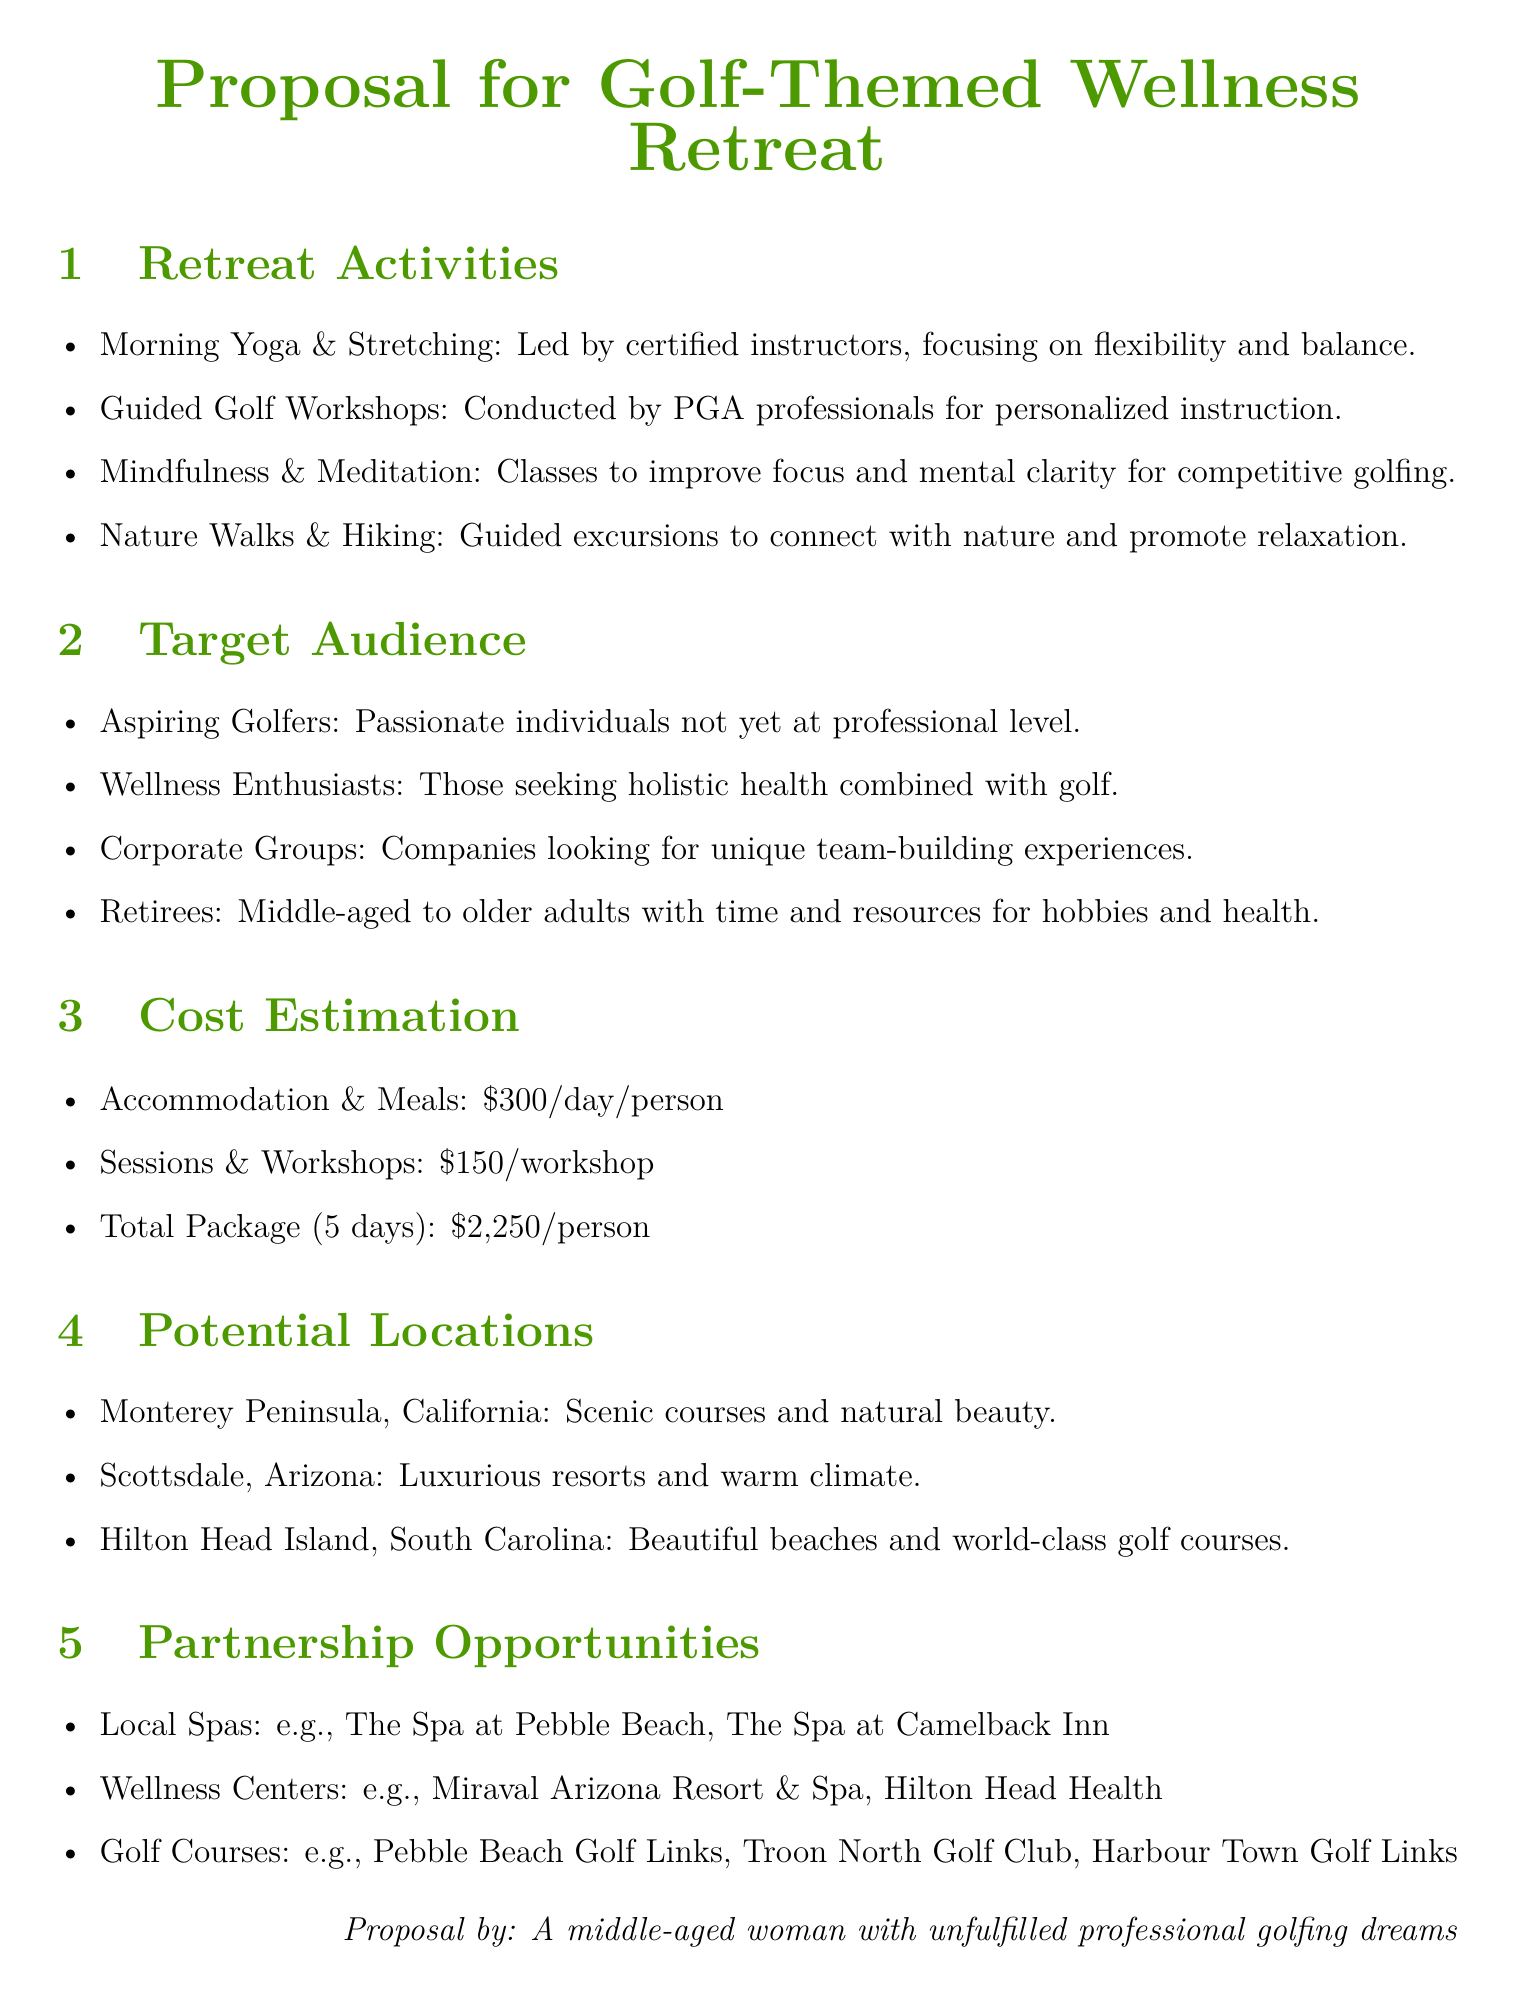What are the retreat activities? The retreat activities are listed as Morning Yoga & Stretching, Guided Golf Workshops, Mindfulness & Meditation, and Nature Walks & Hiking.
Answer: Morning Yoga & Stretching, Guided Golf Workshops, Mindfulness & Meditation, Nature Walks & Hiking Who is the target audience? The target audience is categorized into Aspiring Golfers, Wellness Enthusiasts, Corporate Groups, and Retirees.
Answer: Aspiring Golfers, Wellness Enthusiasts, Corporate Groups, Retirees What is the cost for accommodation and meals per day? The cost estimation for accommodation and meals is provided as $300/day/person.
Answer: $300/day/person How much does the total package cost for five days? The total package cost for five days is specified in the costing section as $2,250/person.
Answer: $2,250/person Name one potential location for the retreat. The document lists potential locations including Monterey Peninsula, California, Scottsdale, Arizona, and Hilton Head Island, South Carolina.
Answer: Monterey Peninsula, California What type of workshops are offered? The workshops mentioned in the retreat activities include Guided Golf Workshops and Mindfulness & Meditation.
Answer: Guided Golf Workshops, Mindfulness & Meditation Which local spa is mentioned as a partnership opportunity? One of the local spas mentioned for partnership is The Spa at Pebble Beach.
Answer: The Spa at Pebble Beach What kind of groups are considered corporate audiences? The document specifies companies looking for unique team-building experiences as a part of the corporate audience.
Answer: Companies looking for unique team-building experiences 